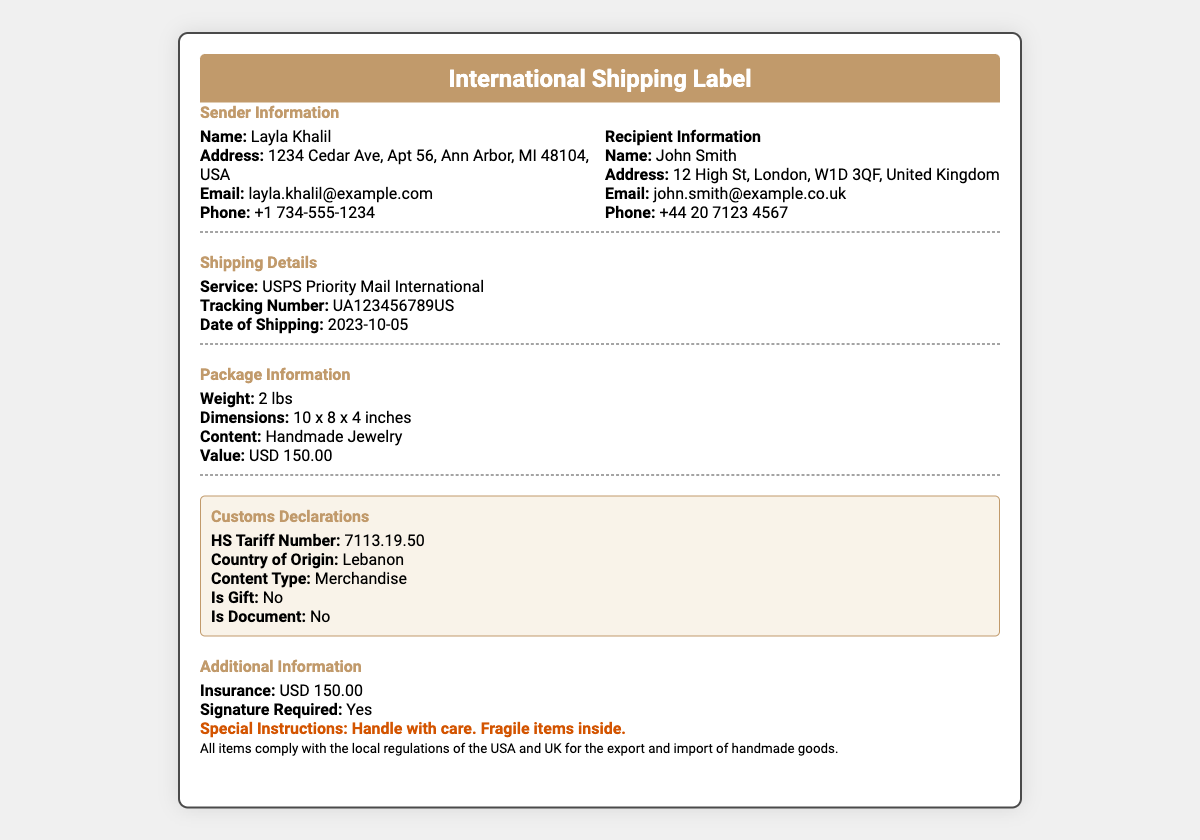What is the name of the sender? The sender's name is stated at the top of the sender information section.
Answer: Layla Khalil What is the recipient's address? The recipient's address is provided in the recipient information section.
Answer: 12 High St, London, W1D 3QF, United Kingdom What is the weight of the package? The weight of the package is listed in the package information section.
Answer: 2 lbs What is the service used for shipping? The shipping service is mentioned in the shipping details section.
Answer: USPS Priority Mail International What is the date of shipping? The date of shipping is specified in the shipping details section.
Answer: 2023-10-05 What is the content type listed in the customs declarations? The content type can be found in the customs declarations section.
Answer: Merchandise What is the value declared for the package? The value of the package is included in the package information section.
Answer: USD 150.00 Is insurance included for this shipment? Insurance information is found in the additional information section.
Answer: Yes What special instruction is provided for handling the package? The special instruction is noted in the additional information section.
Answer: Handle with care. Fragile items inside 